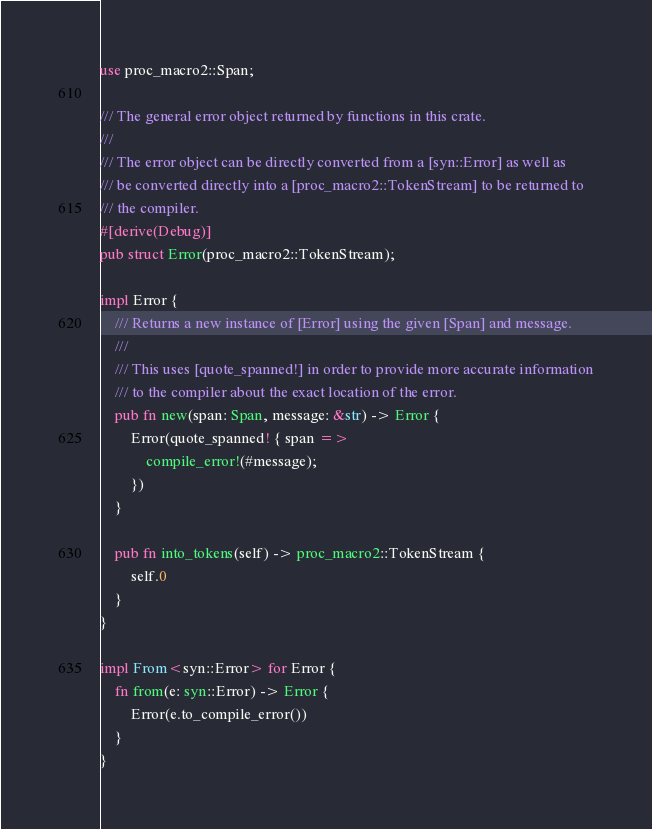Convert code to text. <code><loc_0><loc_0><loc_500><loc_500><_Rust_>use proc_macro2::Span;

/// The general error object returned by functions in this crate.
///
/// The error object can be directly converted from a [syn::Error] as well as
/// be converted directly into a [proc_macro2::TokenStream] to be returned to
/// the compiler.
#[derive(Debug)]
pub struct Error(proc_macro2::TokenStream);

impl Error {
    /// Returns a new instance of [Error] using the given [Span] and message.
    ///
    /// This uses [quote_spanned!] in order to provide more accurate information
    /// to the compiler about the exact location of the error.
    pub fn new(span: Span, message: &str) -> Error {
        Error(quote_spanned! { span =>
            compile_error!(#message);
        })
    }

    pub fn into_tokens(self) -> proc_macro2::TokenStream {
        self.0
    }
}

impl From<syn::Error> for Error {
    fn from(e: syn::Error) -> Error {
        Error(e.to_compile_error())
    }
}
</code> 